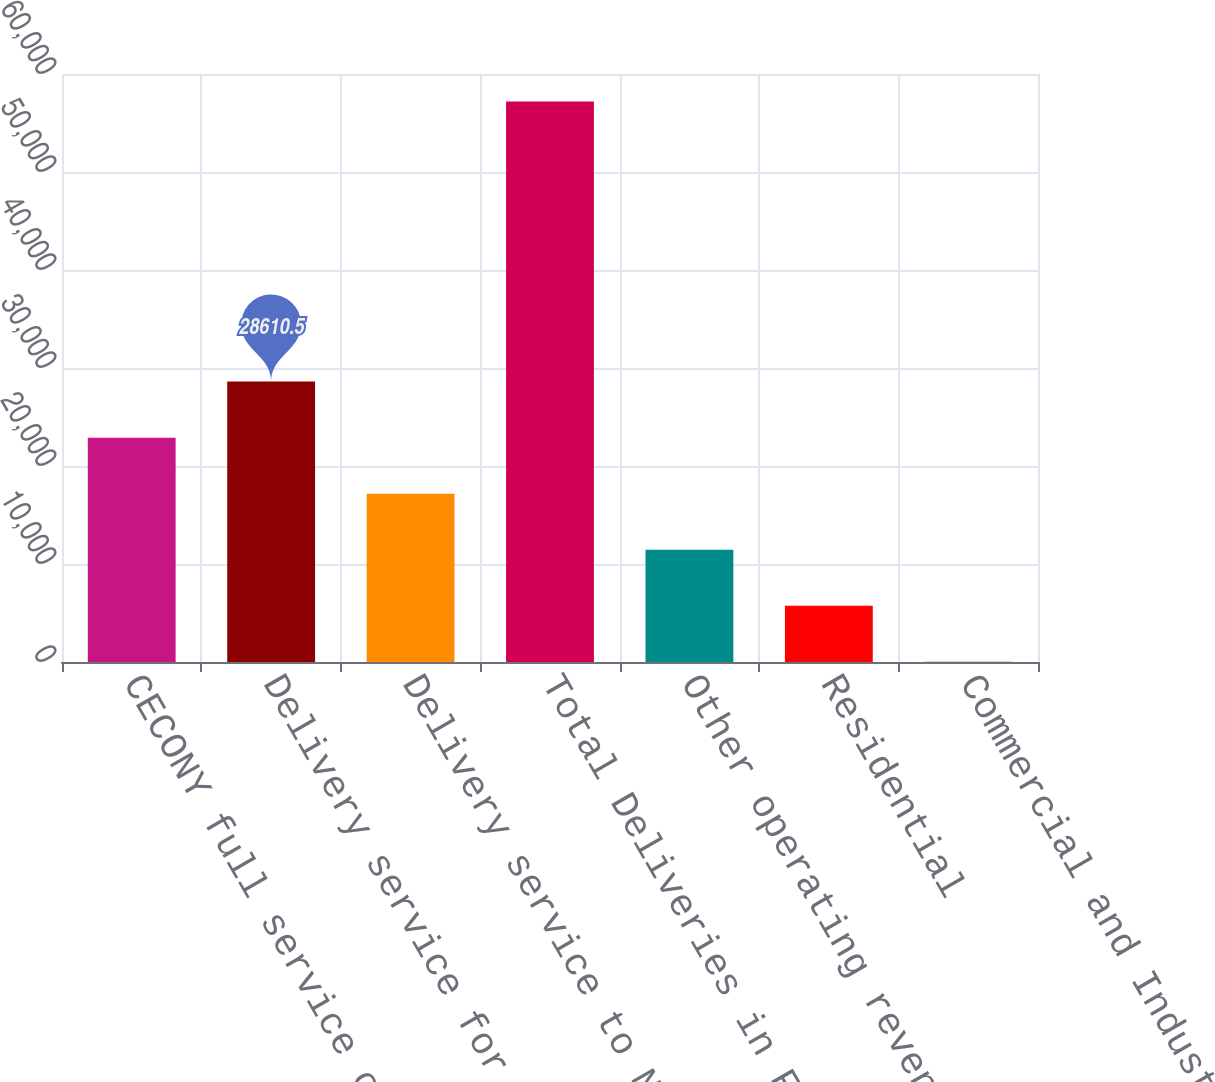Convert chart. <chart><loc_0><loc_0><loc_500><loc_500><bar_chart><fcel>CECONY full service customers<fcel>Delivery service for energy<fcel>Delivery service to NYPA<fcel>Total Deliveries in Franchise<fcel>Other operating revenues<fcel>Residential<fcel>Commercial and Industrial<nl><fcel>22892.4<fcel>28610.5<fcel>17174.3<fcel>57201<fcel>11456.2<fcel>5738.1<fcel>20<nl></chart> 